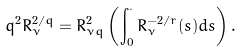Convert formula to latex. <formula><loc_0><loc_0><loc_500><loc_500>q ^ { 2 } R _ { \nu } ^ { 2 / q } = R _ { \nu q } ^ { 2 } \left ( \int _ { 0 } ^ { \cdot } R _ { \nu } ^ { - 2 / r } ( s ) d s \right ) .</formula> 